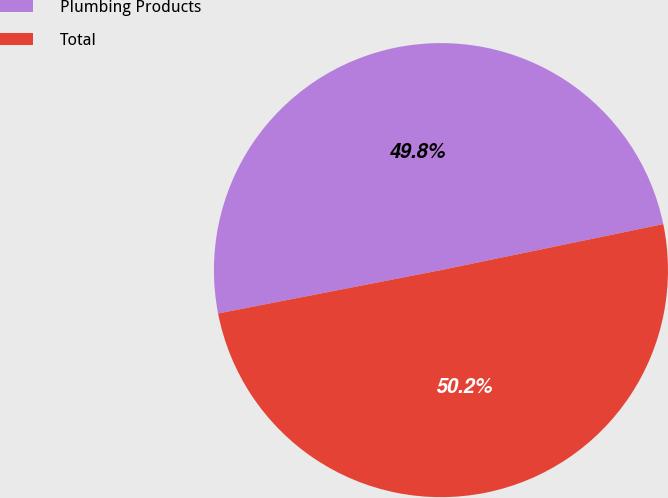Convert chart. <chart><loc_0><loc_0><loc_500><loc_500><pie_chart><fcel>Plumbing Products<fcel>Total<nl><fcel>49.81%<fcel>50.19%<nl></chart> 